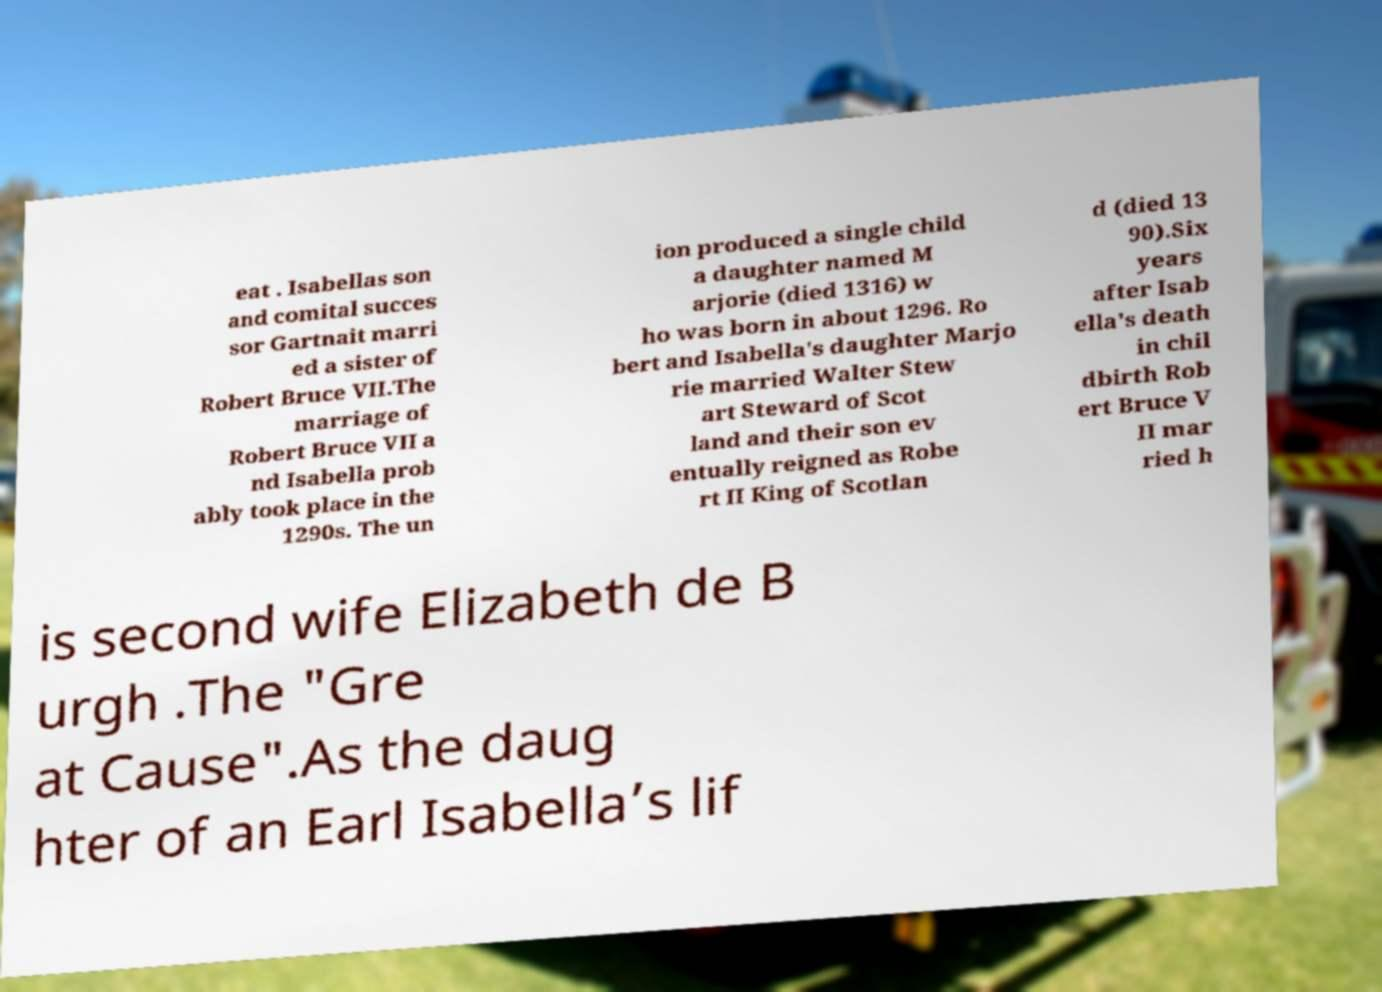There's text embedded in this image that I need extracted. Can you transcribe it verbatim? eat . Isabellas son and comital succes sor Gartnait marri ed a sister of Robert Bruce VII.The marriage of Robert Bruce VII a nd Isabella prob ably took place in the 1290s. The un ion produced a single child a daughter named M arjorie (died 1316) w ho was born in about 1296. Ro bert and Isabella's daughter Marjo rie married Walter Stew art Steward of Scot land and their son ev entually reigned as Robe rt II King of Scotlan d (died 13 90).Six years after Isab ella's death in chil dbirth Rob ert Bruce V II mar ried h is second wife Elizabeth de B urgh .The "Gre at Cause".As the daug hter of an Earl Isabella’s lif 